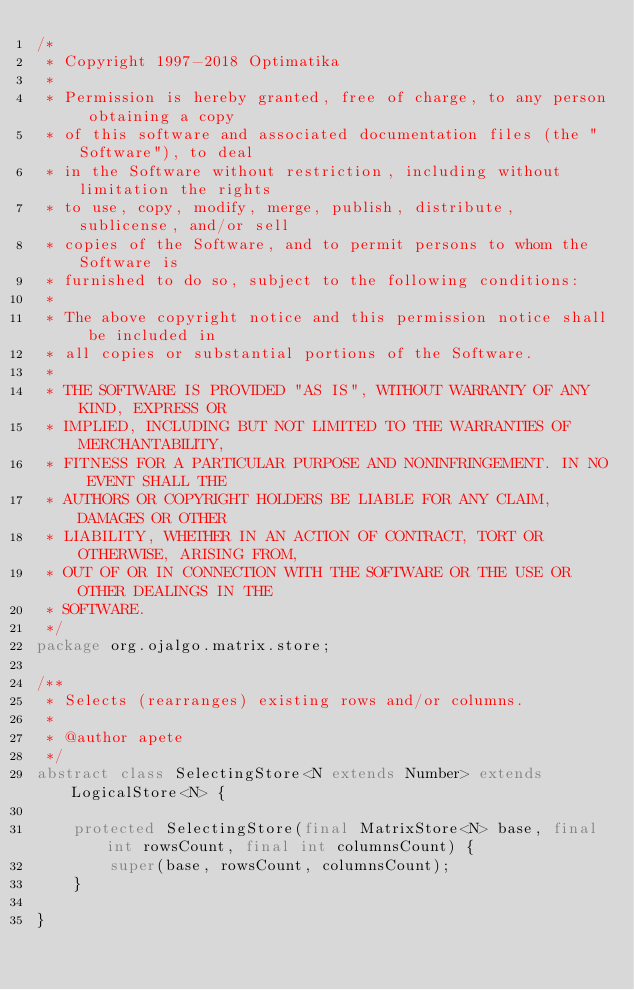Convert code to text. <code><loc_0><loc_0><loc_500><loc_500><_Java_>/*
 * Copyright 1997-2018 Optimatika
 *
 * Permission is hereby granted, free of charge, to any person obtaining a copy
 * of this software and associated documentation files (the "Software"), to deal
 * in the Software without restriction, including without limitation the rights
 * to use, copy, modify, merge, publish, distribute, sublicense, and/or sell
 * copies of the Software, and to permit persons to whom the Software is
 * furnished to do so, subject to the following conditions:
 *
 * The above copyright notice and this permission notice shall be included in
 * all copies or substantial portions of the Software.
 *
 * THE SOFTWARE IS PROVIDED "AS IS", WITHOUT WARRANTY OF ANY KIND, EXPRESS OR
 * IMPLIED, INCLUDING BUT NOT LIMITED TO THE WARRANTIES OF MERCHANTABILITY,
 * FITNESS FOR A PARTICULAR PURPOSE AND NONINFRINGEMENT. IN NO EVENT SHALL THE
 * AUTHORS OR COPYRIGHT HOLDERS BE LIABLE FOR ANY CLAIM, DAMAGES OR OTHER
 * LIABILITY, WHETHER IN AN ACTION OF CONTRACT, TORT OR OTHERWISE, ARISING FROM,
 * OUT OF OR IN CONNECTION WITH THE SOFTWARE OR THE USE OR OTHER DEALINGS IN THE
 * SOFTWARE.
 */
package org.ojalgo.matrix.store;

/**
 * Selects (rearranges) existing rows and/or columns.
 *
 * @author apete
 */
abstract class SelectingStore<N extends Number> extends LogicalStore<N> {

    protected SelectingStore(final MatrixStore<N> base, final int rowsCount, final int columnsCount) {
        super(base, rowsCount, columnsCount);
    }

}
</code> 